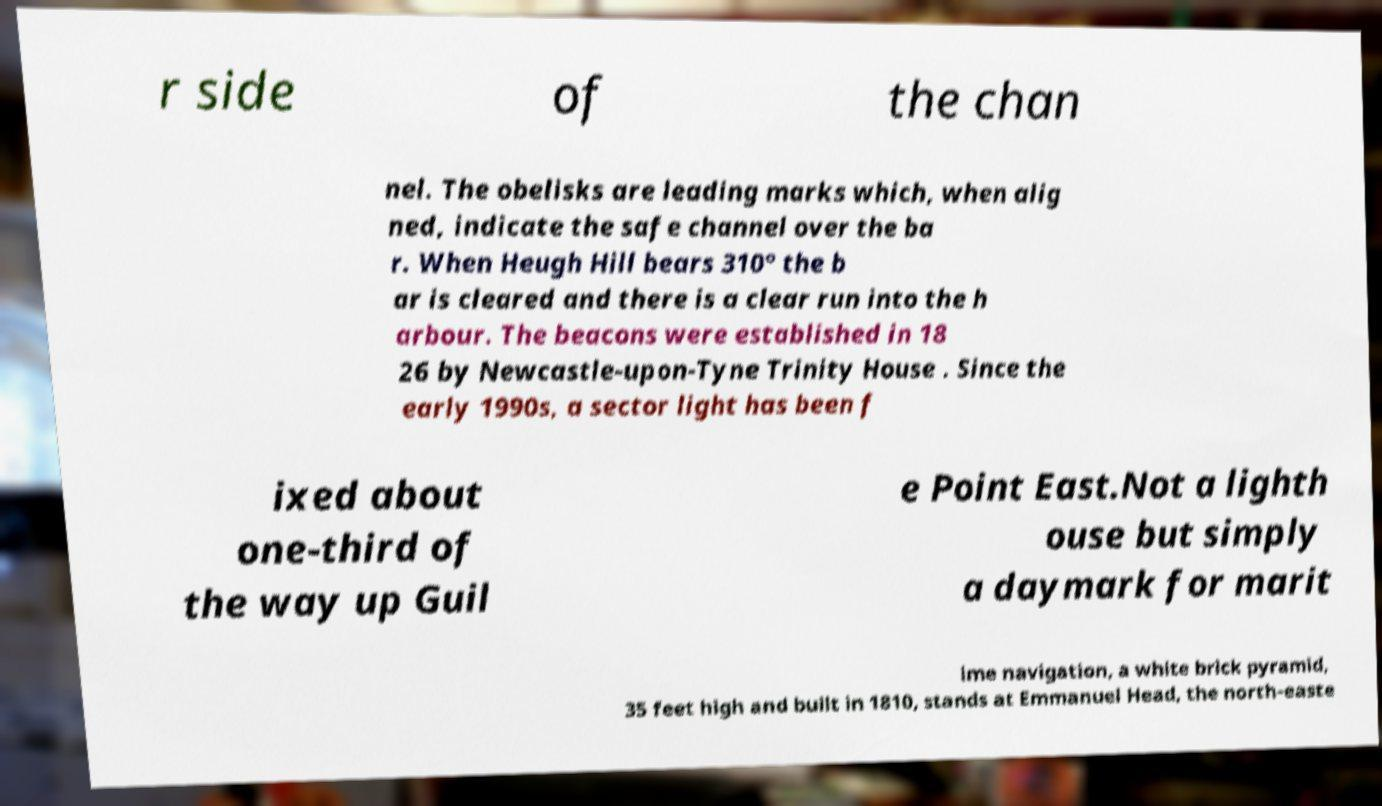Please read and relay the text visible in this image. What does it say? r side of the chan nel. The obelisks are leading marks which, when alig ned, indicate the safe channel over the ba r. When Heugh Hill bears 310° the b ar is cleared and there is a clear run into the h arbour. The beacons were established in 18 26 by Newcastle-upon-Tyne Trinity House . Since the early 1990s, a sector light has been f ixed about one-third of the way up Guil e Point East.Not a lighth ouse but simply a daymark for marit ime navigation, a white brick pyramid, 35 feet high and built in 1810, stands at Emmanuel Head, the north-easte 